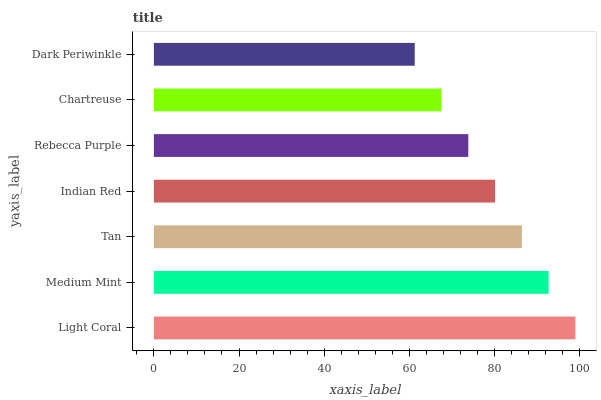Is Dark Periwinkle the minimum?
Answer yes or no. Yes. Is Light Coral the maximum?
Answer yes or no. Yes. Is Medium Mint the minimum?
Answer yes or no. No. Is Medium Mint the maximum?
Answer yes or no. No. Is Light Coral greater than Medium Mint?
Answer yes or no. Yes. Is Medium Mint less than Light Coral?
Answer yes or no. Yes. Is Medium Mint greater than Light Coral?
Answer yes or no. No. Is Light Coral less than Medium Mint?
Answer yes or no. No. Is Indian Red the high median?
Answer yes or no. Yes. Is Indian Red the low median?
Answer yes or no. Yes. Is Dark Periwinkle the high median?
Answer yes or no. No. Is Medium Mint the low median?
Answer yes or no. No. 